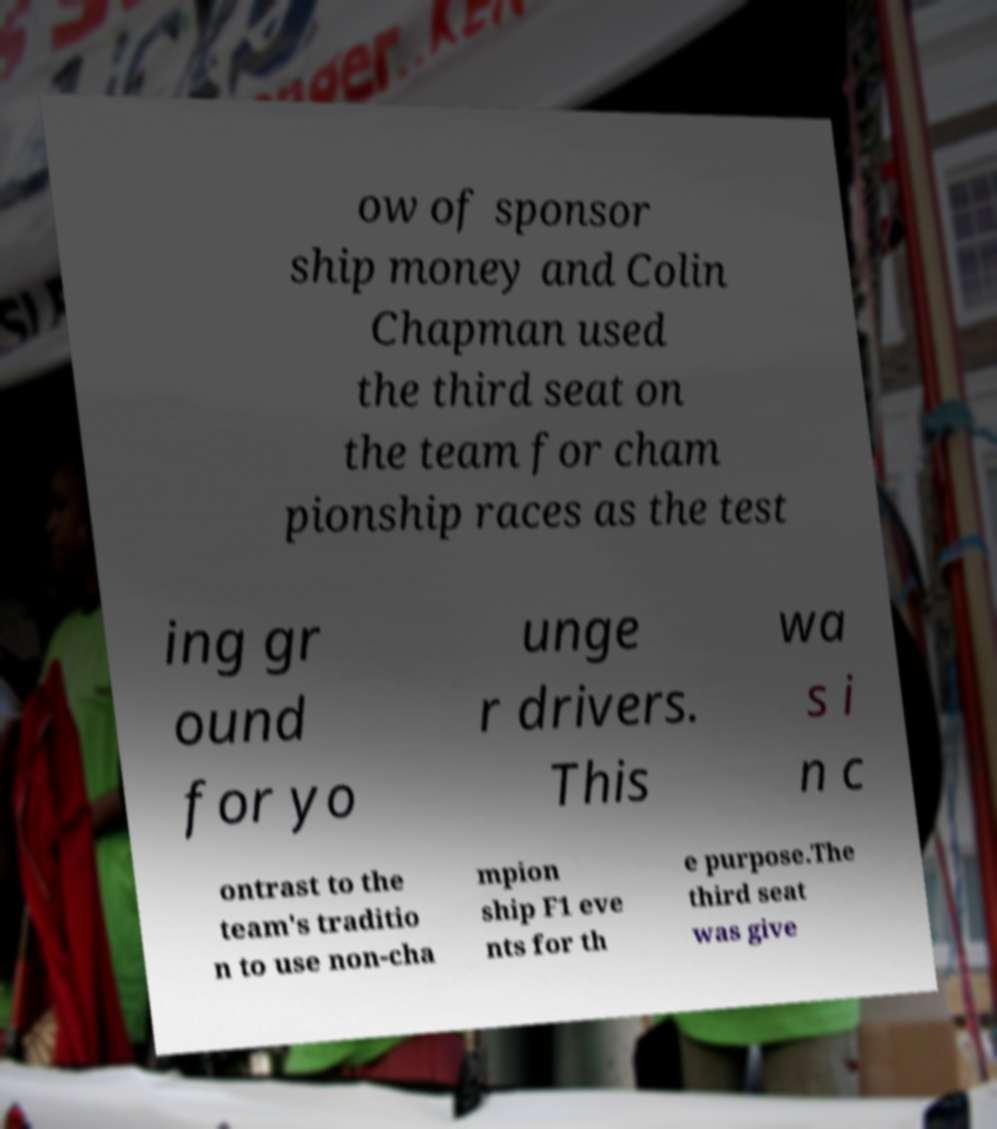Please read and relay the text visible in this image. What does it say? ow of sponsor ship money and Colin Chapman used the third seat on the team for cham pionship races as the test ing gr ound for yo unge r drivers. This wa s i n c ontrast to the team's traditio n to use non-cha mpion ship F1 eve nts for th e purpose.The third seat was give 